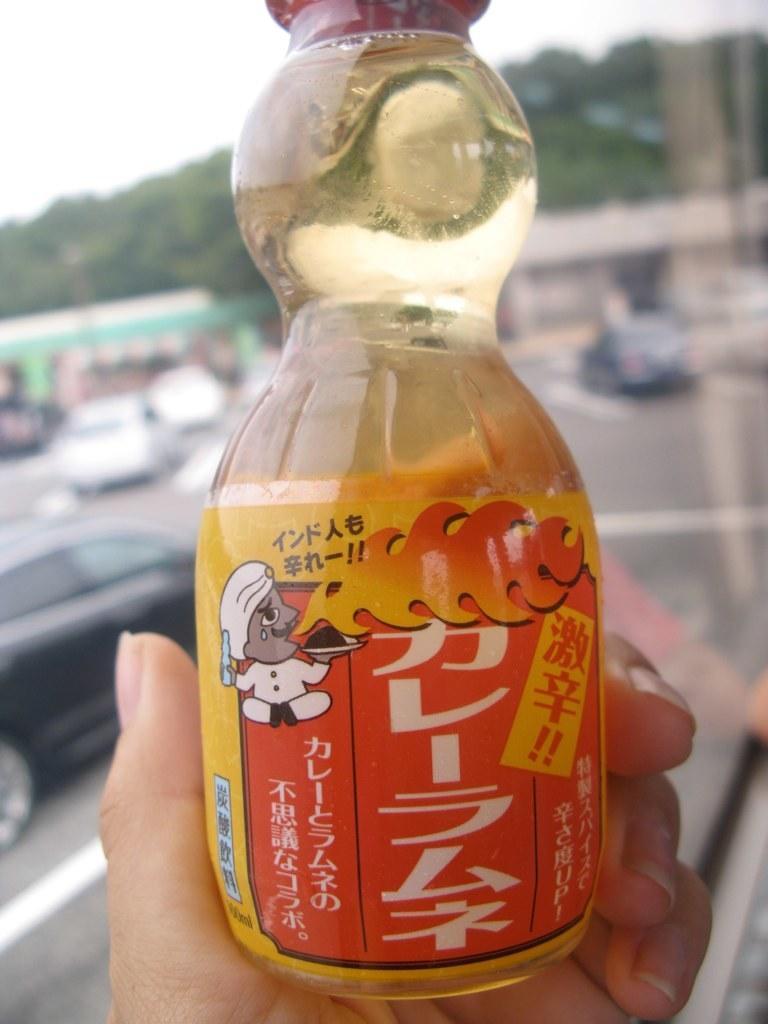Please provide a concise description of this image. In this image I see a person's hand and the person is holding a bottle. In the background I see cars on the road and trees. 